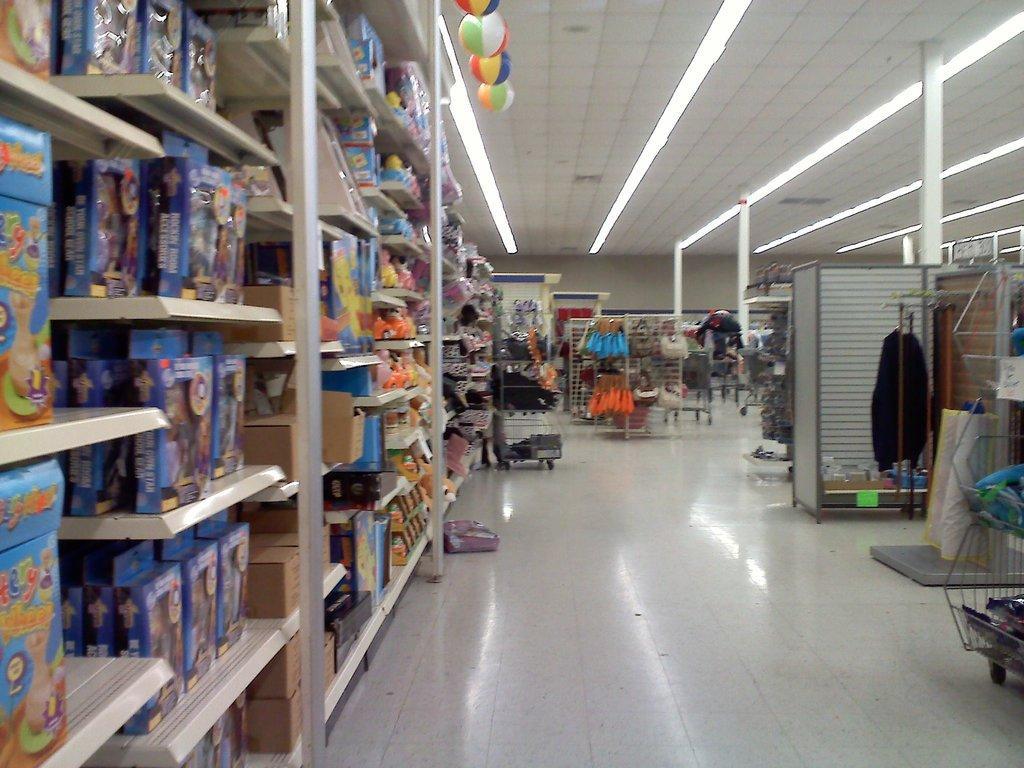Please provide a concise description of this image. On the left side of the image there are a few objects on the rack. On the right side of the image there are few objects. In the background of the image there are bags hanged to the metal rods. At the top of the image there are lights. 